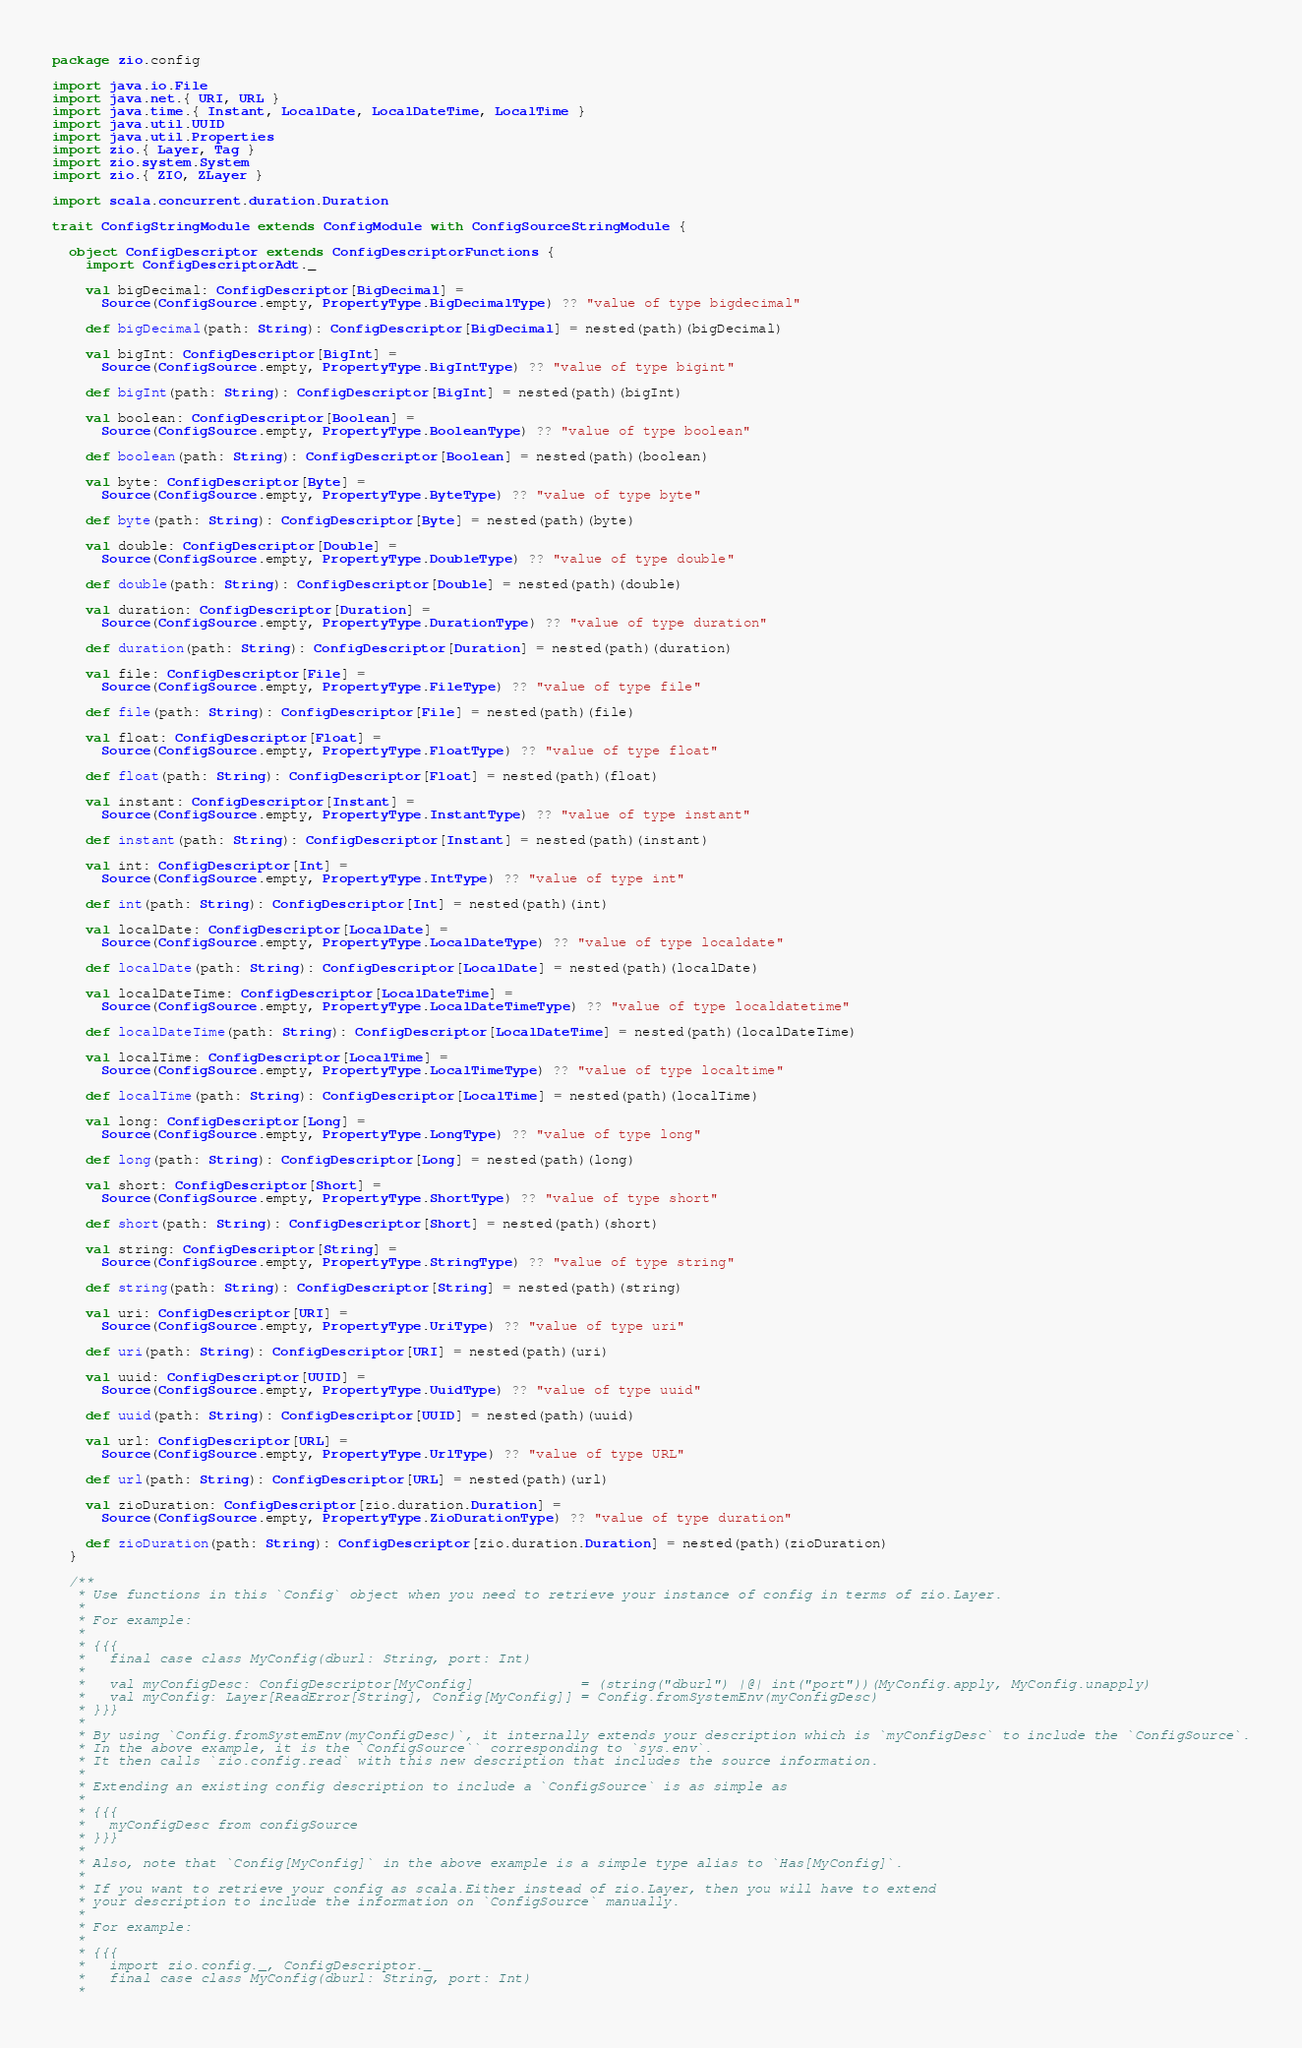Convert code to text. <code><loc_0><loc_0><loc_500><loc_500><_Scala_>package zio.config

import java.io.File
import java.net.{ URI, URL }
import java.time.{ Instant, LocalDate, LocalDateTime, LocalTime }
import java.util.UUID
import java.util.Properties
import zio.{ Layer, Tag }
import zio.system.System
import zio.{ ZIO, ZLayer }

import scala.concurrent.duration.Duration

trait ConfigStringModule extends ConfigModule with ConfigSourceStringModule {

  object ConfigDescriptor extends ConfigDescriptorFunctions {
    import ConfigDescriptorAdt._

    val bigDecimal: ConfigDescriptor[BigDecimal] =
      Source(ConfigSource.empty, PropertyType.BigDecimalType) ?? "value of type bigdecimal"

    def bigDecimal(path: String): ConfigDescriptor[BigDecimal] = nested(path)(bigDecimal)

    val bigInt: ConfigDescriptor[BigInt] =
      Source(ConfigSource.empty, PropertyType.BigIntType) ?? "value of type bigint"

    def bigInt(path: String): ConfigDescriptor[BigInt] = nested(path)(bigInt)

    val boolean: ConfigDescriptor[Boolean] =
      Source(ConfigSource.empty, PropertyType.BooleanType) ?? "value of type boolean"

    def boolean(path: String): ConfigDescriptor[Boolean] = nested(path)(boolean)

    val byte: ConfigDescriptor[Byte] =
      Source(ConfigSource.empty, PropertyType.ByteType) ?? "value of type byte"

    def byte(path: String): ConfigDescriptor[Byte] = nested(path)(byte)

    val double: ConfigDescriptor[Double] =
      Source(ConfigSource.empty, PropertyType.DoubleType) ?? "value of type double"

    def double(path: String): ConfigDescriptor[Double] = nested(path)(double)

    val duration: ConfigDescriptor[Duration] =
      Source(ConfigSource.empty, PropertyType.DurationType) ?? "value of type duration"

    def duration(path: String): ConfigDescriptor[Duration] = nested(path)(duration)

    val file: ConfigDescriptor[File] =
      Source(ConfigSource.empty, PropertyType.FileType) ?? "value of type file"

    def file(path: String): ConfigDescriptor[File] = nested(path)(file)

    val float: ConfigDescriptor[Float] =
      Source(ConfigSource.empty, PropertyType.FloatType) ?? "value of type float"

    def float(path: String): ConfigDescriptor[Float] = nested(path)(float)

    val instant: ConfigDescriptor[Instant] =
      Source(ConfigSource.empty, PropertyType.InstantType) ?? "value of type instant"

    def instant(path: String): ConfigDescriptor[Instant] = nested(path)(instant)

    val int: ConfigDescriptor[Int] =
      Source(ConfigSource.empty, PropertyType.IntType) ?? "value of type int"

    def int(path: String): ConfigDescriptor[Int] = nested(path)(int)

    val localDate: ConfigDescriptor[LocalDate] =
      Source(ConfigSource.empty, PropertyType.LocalDateType) ?? "value of type localdate"

    def localDate(path: String): ConfigDescriptor[LocalDate] = nested(path)(localDate)

    val localDateTime: ConfigDescriptor[LocalDateTime] =
      Source(ConfigSource.empty, PropertyType.LocalDateTimeType) ?? "value of type localdatetime"

    def localDateTime(path: String): ConfigDescriptor[LocalDateTime] = nested(path)(localDateTime)

    val localTime: ConfigDescriptor[LocalTime] =
      Source(ConfigSource.empty, PropertyType.LocalTimeType) ?? "value of type localtime"

    def localTime(path: String): ConfigDescriptor[LocalTime] = nested(path)(localTime)

    val long: ConfigDescriptor[Long] =
      Source(ConfigSource.empty, PropertyType.LongType) ?? "value of type long"

    def long(path: String): ConfigDescriptor[Long] = nested(path)(long)

    val short: ConfigDescriptor[Short] =
      Source(ConfigSource.empty, PropertyType.ShortType) ?? "value of type short"

    def short(path: String): ConfigDescriptor[Short] = nested(path)(short)

    val string: ConfigDescriptor[String] =
      Source(ConfigSource.empty, PropertyType.StringType) ?? "value of type string"

    def string(path: String): ConfigDescriptor[String] = nested(path)(string)

    val uri: ConfigDescriptor[URI] =
      Source(ConfigSource.empty, PropertyType.UriType) ?? "value of type uri"

    def uri(path: String): ConfigDescriptor[URI] = nested(path)(uri)

    val uuid: ConfigDescriptor[UUID] =
      Source(ConfigSource.empty, PropertyType.UuidType) ?? "value of type uuid"

    def uuid(path: String): ConfigDescriptor[UUID] = nested(path)(uuid)

    val url: ConfigDescriptor[URL] =
      Source(ConfigSource.empty, PropertyType.UrlType) ?? "value of type URL"

    def url(path: String): ConfigDescriptor[URL] = nested(path)(url)

    val zioDuration: ConfigDescriptor[zio.duration.Duration] =
      Source(ConfigSource.empty, PropertyType.ZioDurationType) ?? "value of type duration"

    def zioDuration(path: String): ConfigDescriptor[zio.duration.Duration] = nested(path)(zioDuration)
  }

  /**
   * Use functions in this `Config` object when you need to retrieve your instance of config in terms of zio.Layer.
   *
   * For example:
   *
   * {{{
   *   final case class MyConfig(dburl: String, port: Int)
   *
   *   val myConfigDesc: ConfigDescriptor[MyConfig]             = (string("dburl") |@| int("port"))(MyConfig.apply, MyConfig.unapply)
   *   val myConfig: Layer[ReadError[String], Config[MyConfig]] = Config.fromSystemEnv(myConfigDesc)
   * }}}
   *
   * By using `Config.fromSystemEnv(myConfigDesc)`, it internally extends your description which is `myConfigDesc` to include the `ConfigSource`.
   * In the above example, it is the `ConfigSource`` corresponding to `sys.env`.
   * It then calls `zio.config.read` with this new description that includes the source information.
   *
   * Extending an existing config description to include a `ConfigSource` is as simple as
   *
   * {{{
   *   myConfigDesc from configSource
   * }}}
   *
   * Also, note that `Config[MyConfig]` in the above example is a simple type alias to `Has[MyConfig]`.
   *
   * If you want to retrieve your config as scala.Either instead of zio.Layer, then you will have to extend
   * your description to include the information on `ConfigSource` manually.
   *
   * For example:
   *
   * {{{
   *   import zio.config._, ConfigDescriptor._
   *   final case class MyConfig(dburl: String, port: Int)
   *</code> 